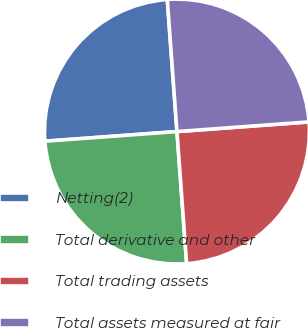Convert chart. <chart><loc_0><loc_0><loc_500><loc_500><pie_chart><fcel>Netting(2)<fcel>Total derivative and other<fcel>Total trading assets<fcel>Total assets measured at fair<nl><fcel>25.0%<fcel>25.0%<fcel>25.0%<fcel>25.0%<nl></chart> 